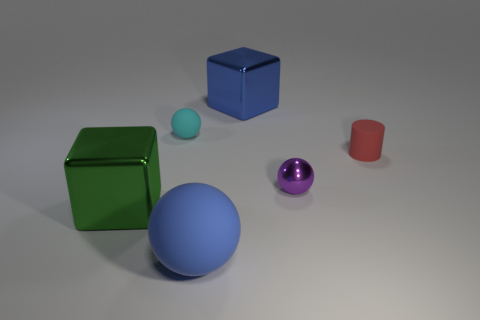Add 3 tiny red matte objects. How many objects exist? 9 Subtract all cylinders. How many objects are left? 5 Subtract 0 blue cylinders. How many objects are left? 6 Subtract all red shiny cubes. Subtract all tiny cyan rubber things. How many objects are left? 5 Add 4 red cylinders. How many red cylinders are left? 5 Add 3 small rubber blocks. How many small rubber blocks exist? 3 